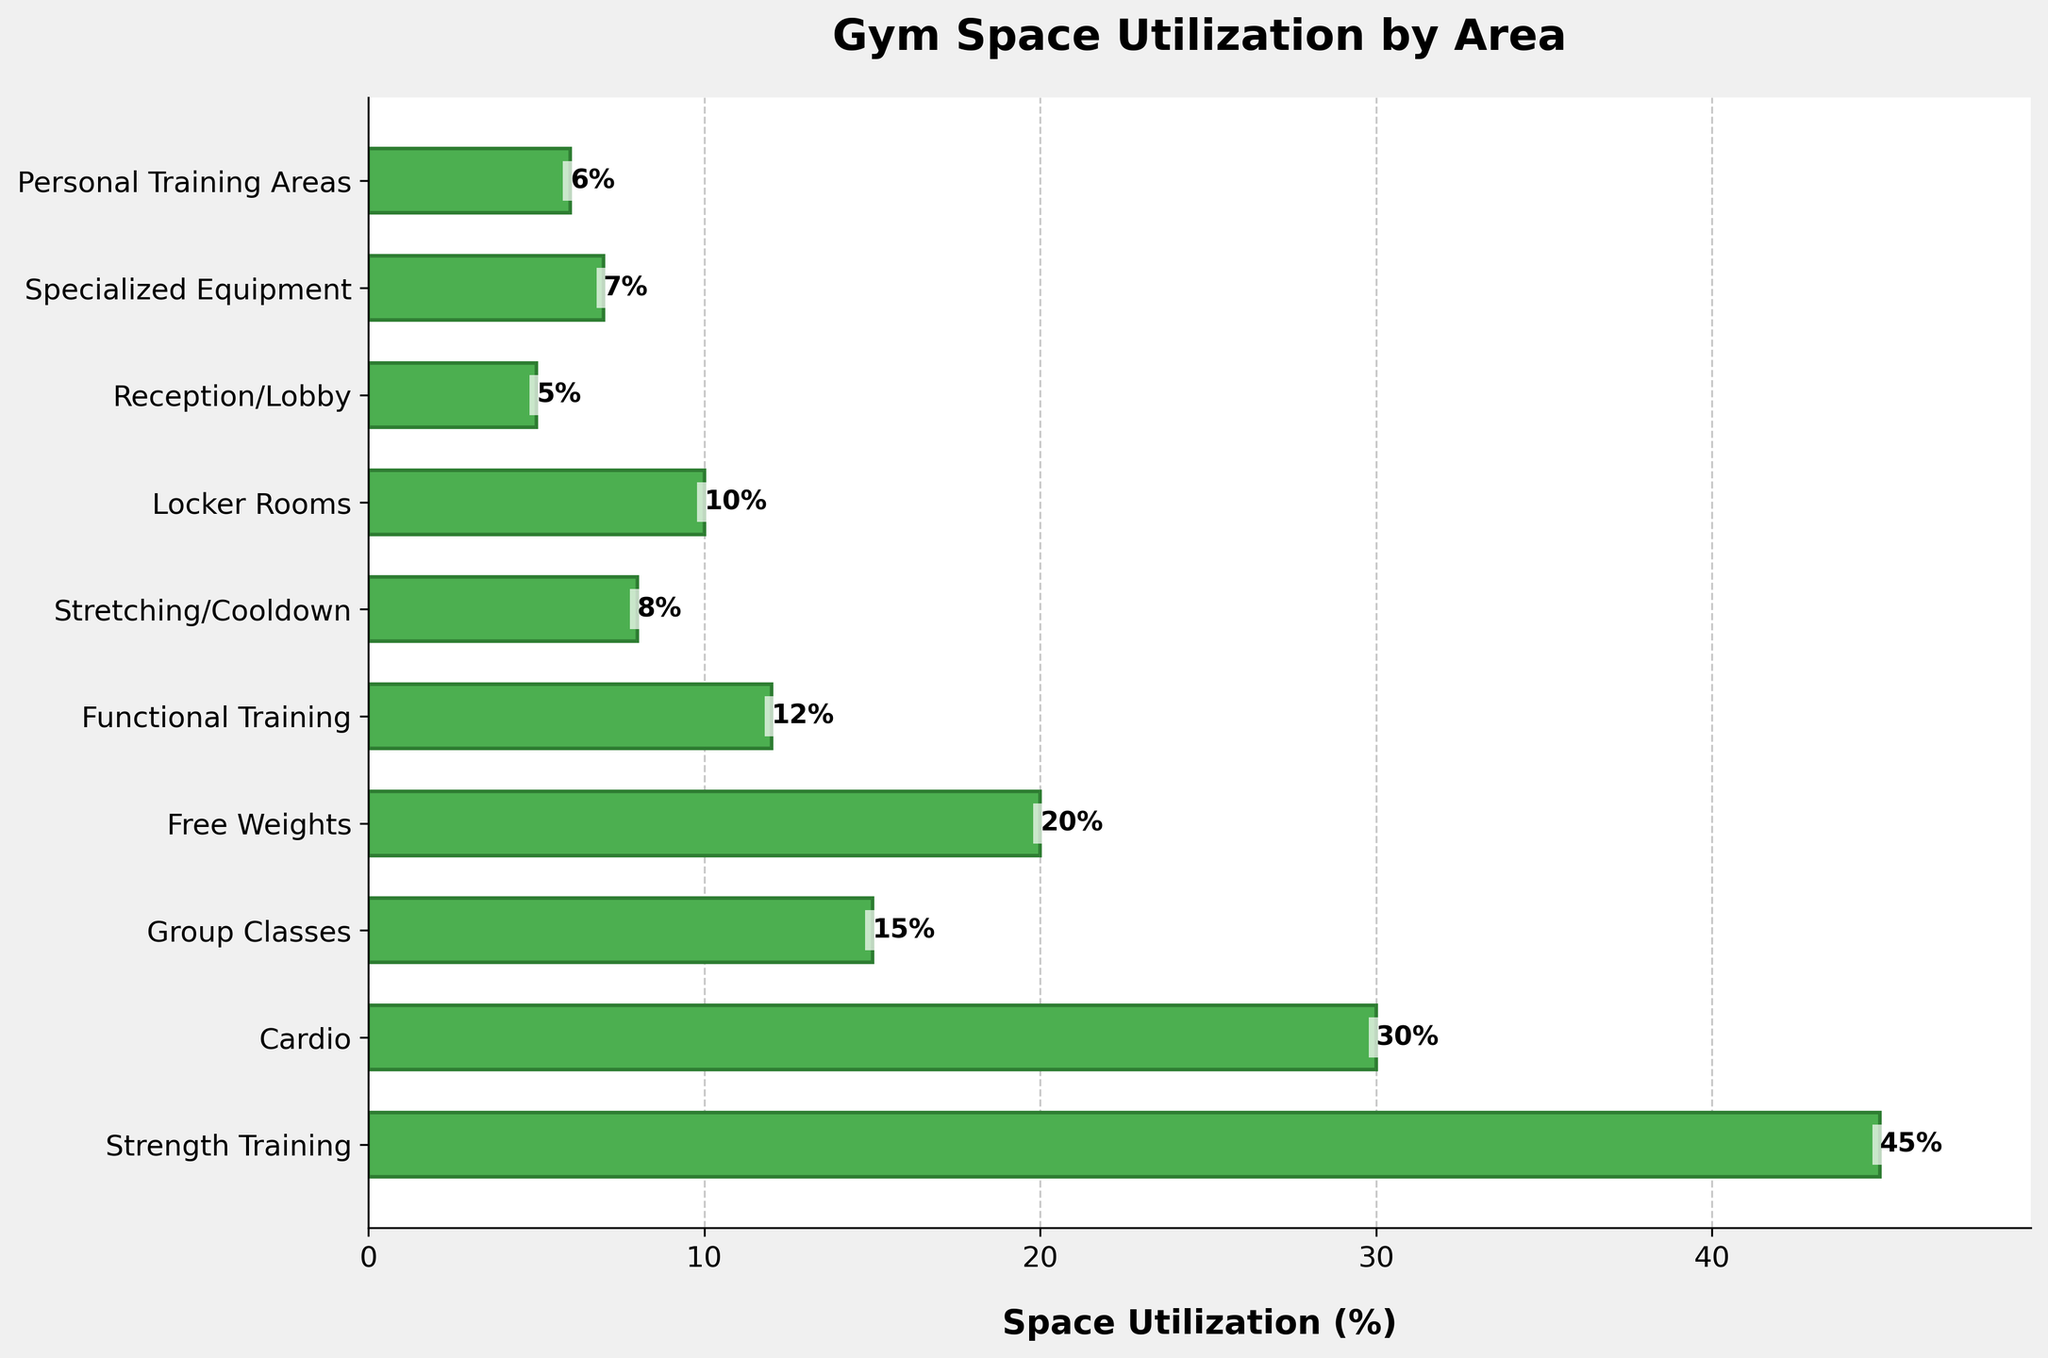Which area has the highest space utilization? The bar chart shows a label indicating the percentage of space utilized by each area. The area with the highest percentage is Strength Training at 45%.
Answer: Strength Training What is the combined space utilization of Cardio and Free Weights areas? The chart provides percentages for Cardio (30%) and Free Weights (20%). Adding these two values gives 30% + 20% = 50%.
Answer: 50% How much more space is allocated to Strength Training than to Stretching/Cooldown? Strength Training is allocated 45%, while Stretching/Cooldown gets 8%. The difference is 45% - 8% = 37%.
Answer: 37% Which areas have a space utilization of less than 10%? The corresponding bars for Reception/Lobby (5%), Specialized Equipment (7%), Personal Training Areas (6%), and Stretching/Cooldown (8%) all fall under 10%.
Answer: Reception/Lobby, Specialized Equipment, Personal Training Areas, Stretching/Cooldown What is the average space utilization for Group Classes, Locker Rooms, and Cardio? To find the average, sum the percentages for Group Classes (15%), Locker Rooms (10%), and Cardio (30%) and then divide by the number of areas: (15% + 10% + 30%) / 3 = 55% / 3 ≈ 18.33%.
Answer: 18.33% Compare the space utilization of Functional Training and Reception/Lobby. Functional Training has 12% space utilization while Reception/Lobby has 5%. Functional Training, thus, utilizes more space.
Answer: Functional Training What is the total space utilization of all areas used for various types of training (Strength Training, Cardio, Free Weights, Functional Training, Group Classes)? The respective percentages are: Strength Training (45%), Cardio (30%), Free Weights (20%), Functional Training (12%), Group Classes (15%). The sum is 45% + 30% + 20% + 12% + 15% = 122%.
Answer: 122% Which area has the least space utilization? According to the bar lengths and labeled percentages in the chart, Reception/Lobby has the least utilization at 5%.
Answer: Reception/Lobby How much more space utilization does Strength Training have compared to the next highest area? Strength Training is 45%, and the next highest is Cardio at 30%. The difference is 45% - 30% = 15%.
Answer: 15% Of the areas allocated less than 15% of space, which is utilized more: Specialized Equipment or Personal Training Areas? Specialized Equipment has 7% utilization, while Personal Training Areas have 6%. Thus, Specialized Equipment has higher utilization among the two.
Answer: Specialized Equipment 